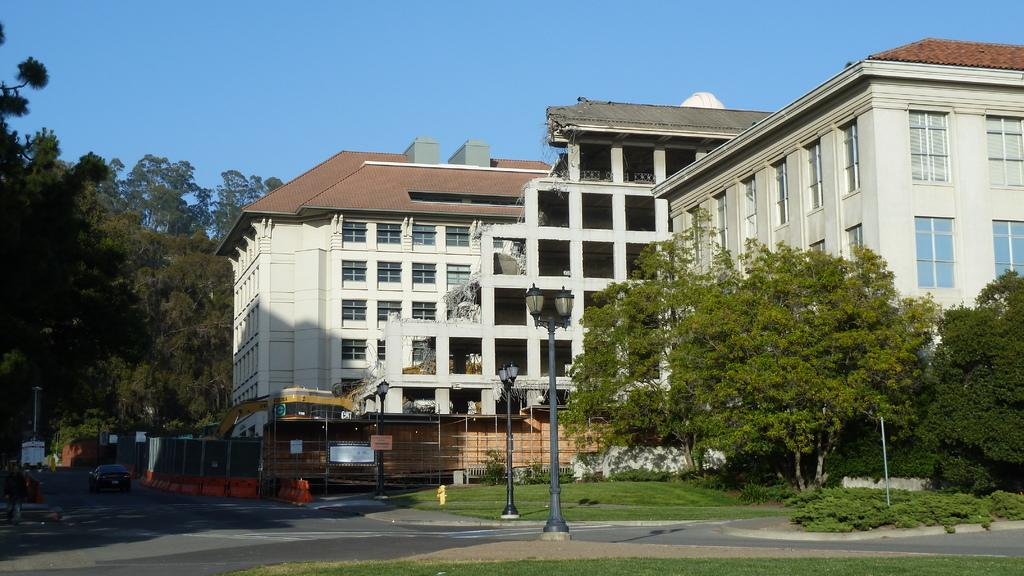What is the main feature of the image? There is a road in the image. What else can be seen along the road? There are poles, lights, grass, plants, trees, vehicles, a fire hydrant, and buildings in the image. What is visible in the background of the image? The sky is visible in the background of the image. What type of apparel is the egg wearing in the image? There is no egg or apparel present in the image. How many beads are hanging from the trees in the image? There are no beads hanging from the trees in the image; only lights are present. 